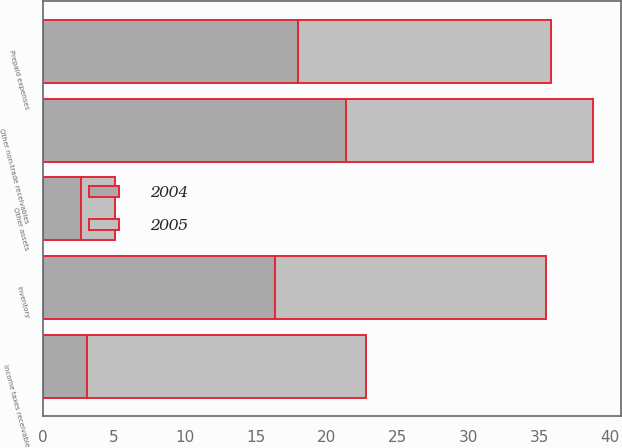Convert chart to OTSL. <chart><loc_0><loc_0><loc_500><loc_500><stacked_bar_chart><ecel><fcel>Inventory<fcel>Prepaid expenses<fcel>Other non-trade receivables<fcel>Income taxes receivable<fcel>Other assets<nl><fcel>2004<fcel>16.4<fcel>18<fcel>21.4<fcel>3.1<fcel>2.7<nl><fcel>2005<fcel>19.1<fcel>17.8<fcel>17.4<fcel>19.7<fcel>2.4<nl></chart> 